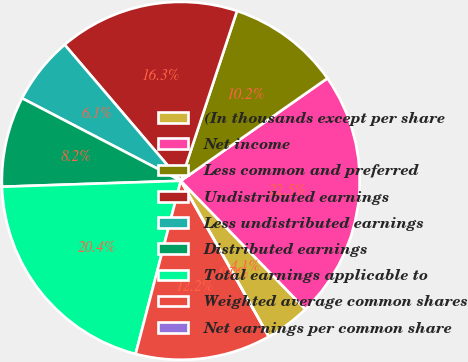Convert chart to OTSL. <chart><loc_0><loc_0><loc_500><loc_500><pie_chart><fcel>(In thousands except per share<fcel>Net income<fcel>Less common and preferred<fcel>Undistributed earnings<fcel>Less undistributed earnings<fcel>Distributed earnings<fcel>Total earnings applicable to<fcel>Weighted average common shares<fcel>Net earnings per common share<nl><fcel>4.08%<fcel>22.45%<fcel>10.2%<fcel>16.33%<fcel>6.12%<fcel>8.16%<fcel>20.41%<fcel>12.24%<fcel>0.0%<nl></chart> 